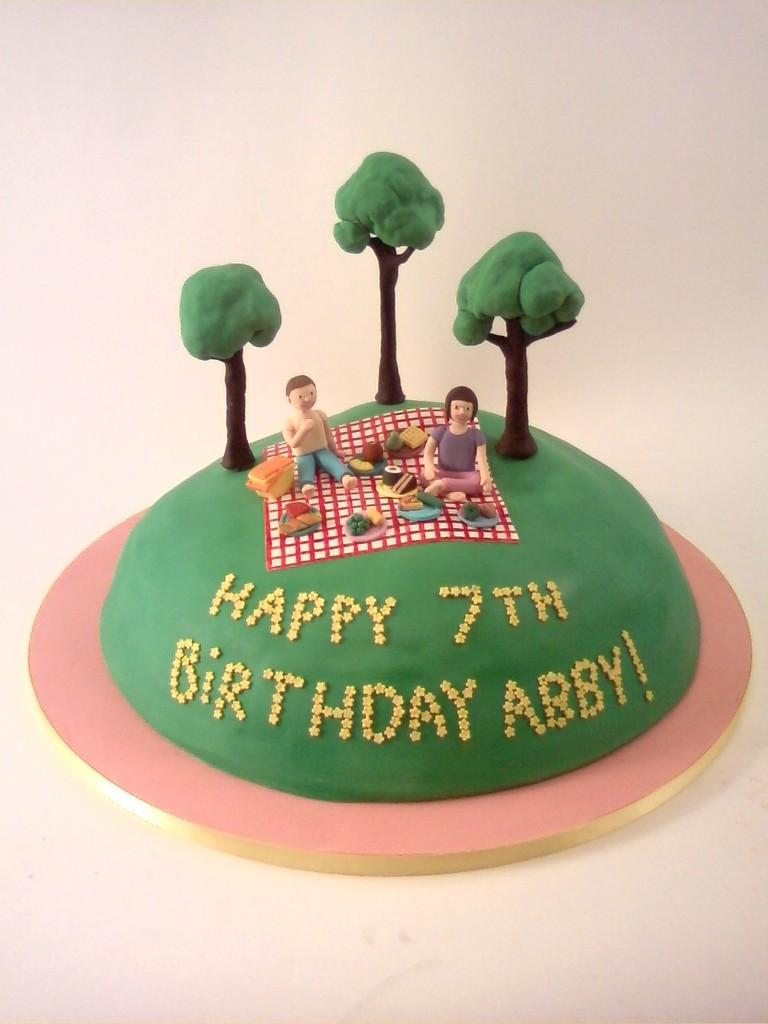What is the main subject in the center of the image? There is a cake in the center of the image. What can be seen on the cake's surface? The cake has depictions of persons and trees. What is the background or surface visible at the bottom of the image? There is a surface at the bottom of the image. What type of thread is used to decorate the cake in the image? There is no thread visible on the cake in the image. What color is the pen used to draw the trees on the cake? There is no pen or drawing involved in the decoration of the cake in the image; it has depictions of trees. 